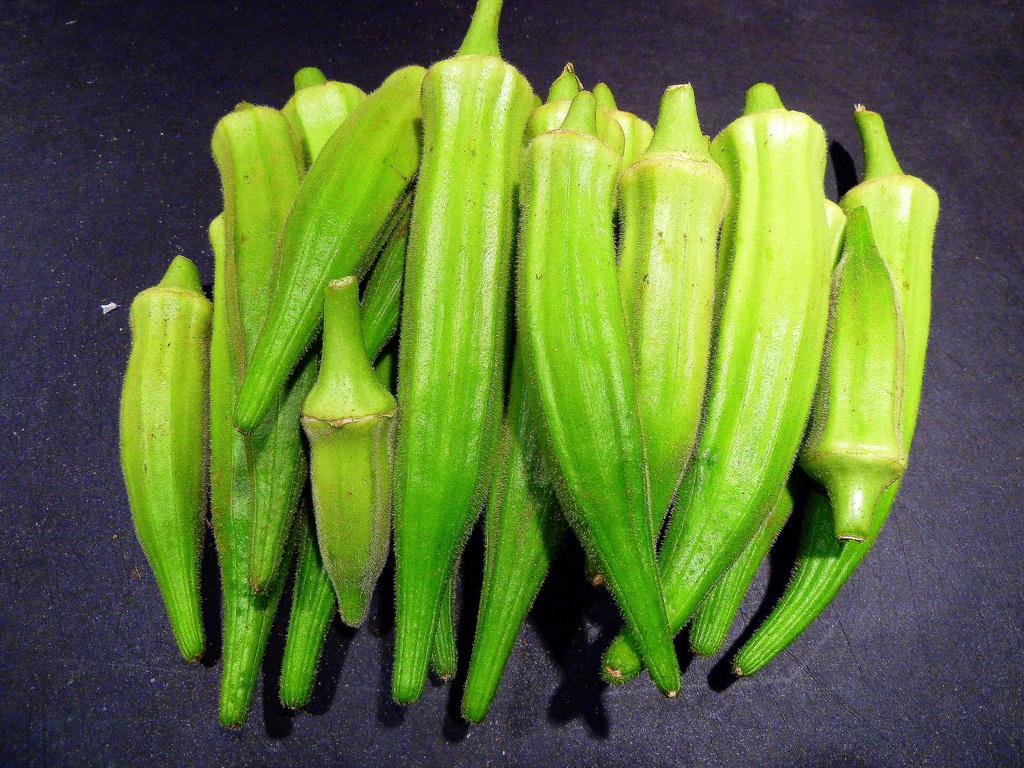What is placed in the image? There are lady fingers placed in the image. Can you describe the appearance of the lady fingers? The lady fingers appear to be small, finger-shaped pastries. Are there any other objects or figures accompanying the lady fingers in the image? The image only shows the lady fingers placed on a surface. What type of furniture can be seen supporting the lady fingers in the image? There is no furniture visible in the image; the lady fingers are placed on a surface, but it is not specified as a piece of furniture. 